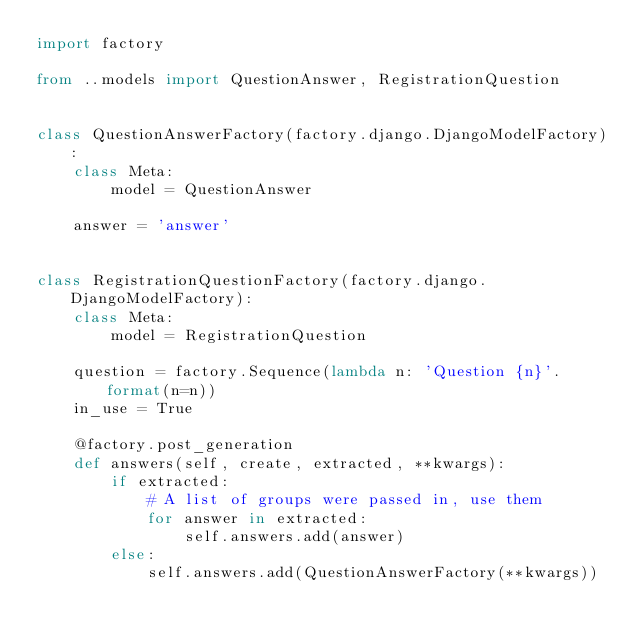Convert code to text. <code><loc_0><loc_0><loc_500><loc_500><_Python_>import factory

from ..models import QuestionAnswer, RegistrationQuestion


class QuestionAnswerFactory(factory.django.DjangoModelFactory):
    class Meta:
        model = QuestionAnswer

    answer = 'answer'


class RegistrationQuestionFactory(factory.django.DjangoModelFactory):
    class Meta:
        model = RegistrationQuestion

    question = factory.Sequence(lambda n: 'Question {n}'.format(n=n))
    in_use = True

    @factory.post_generation
    def answers(self, create, extracted, **kwargs):
        if extracted:
            # A list of groups were passed in, use them
            for answer in extracted:
                self.answers.add(answer)
        else:
            self.answers.add(QuestionAnswerFactory(**kwargs))
</code> 